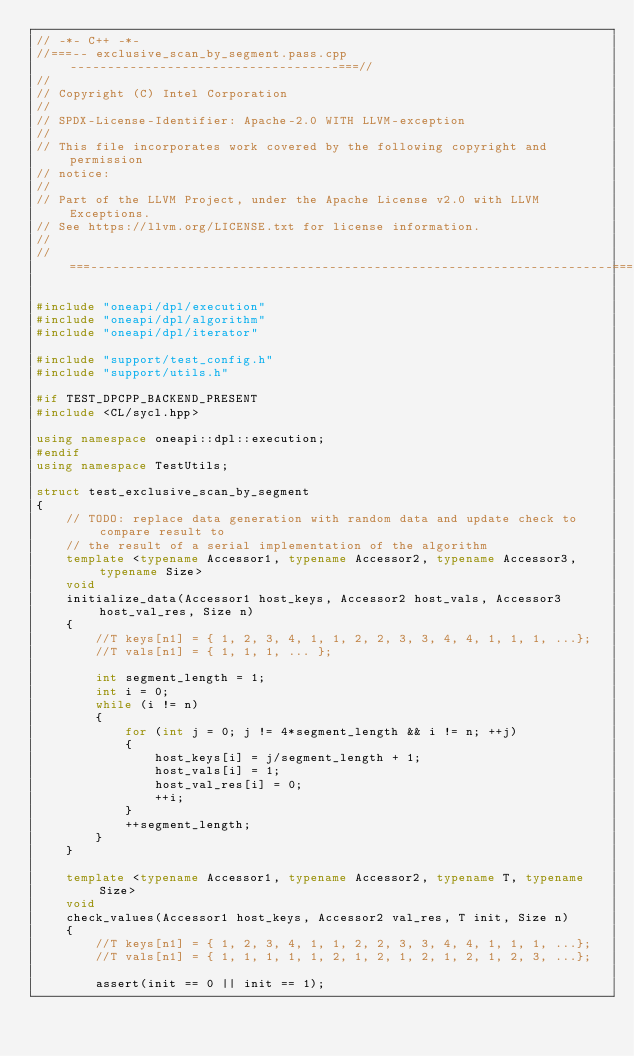<code> <loc_0><loc_0><loc_500><loc_500><_C++_>// -*- C++ -*-
//===-- exclusive_scan_by_segment.pass.cpp ------------------------------------===//
//
// Copyright (C) Intel Corporation
//
// SPDX-License-Identifier: Apache-2.0 WITH LLVM-exception
//
// This file incorporates work covered by the following copyright and permission
// notice:
//
// Part of the LLVM Project, under the Apache License v2.0 with LLVM Exceptions.
// See https://llvm.org/LICENSE.txt for license information.
//
//===----------------------------------------------------------------------===//

#include "oneapi/dpl/execution"
#include "oneapi/dpl/algorithm"
#include "oneapi/dpl/iterator"

#include "support/test_config.h"
#include "support/utils.h"

#if TEST_DPCPP_BACKEND_PRESENT
#include <CL/sycl.hpp>

using namespace oneapi::dpl::execution;
#endif
using namespace TestUtils;

struct test_exclusive_scan_by_segment
{
    // TODO: replace data generation with random data and update check to compare result to
    // the result of a serial implementation of the algorithm
    template <typename Accessor1, typename Accessor2, typename Accessor3, typename Size>
    void
    initialize_data(Accessor1 host_keys, Accessor2 host_vals, Accessor3 host_val_res, Size n)
    {
        //T keys[n1] = { 1, 2, 3, 4, 1, 1, 2, 2, 3, 3, 4, 4, 1, 1, 1, ...};
        //T vals[n1] = { 1, 1, 1, ... };

        int segment_length = 1;
        int i = 0;
        while (i != n)
        {
            for (int j = 0; j != 4*segment_length && i != n; ++j)
            {
                host_keys[i] = j/segment_length + 1;
                host_vals[i] = 1;
                host_val_res[i] = 0;
                ++i;
            }
            ++segment_length;
        }
    }

    template <typename Accessor1, typename Accessor2, typename T, typename Size>
    void
    check_values(Accessor1 host_keys, Accessor2 val_res, T init, Size n)
    {
        //T keys[n1] = { 1, 2, 3, 4, 1, 1, 2, 2, 3, 3, 4, 4, 1, 1, 1, ...};
        //T vals[n1] = { 1, 1, 1, 1, 1, 2, 1, 2, 1, 2, 1, 2, 1, 2, 3, ...};

        assert(init == 0 || init == 1);</code> 